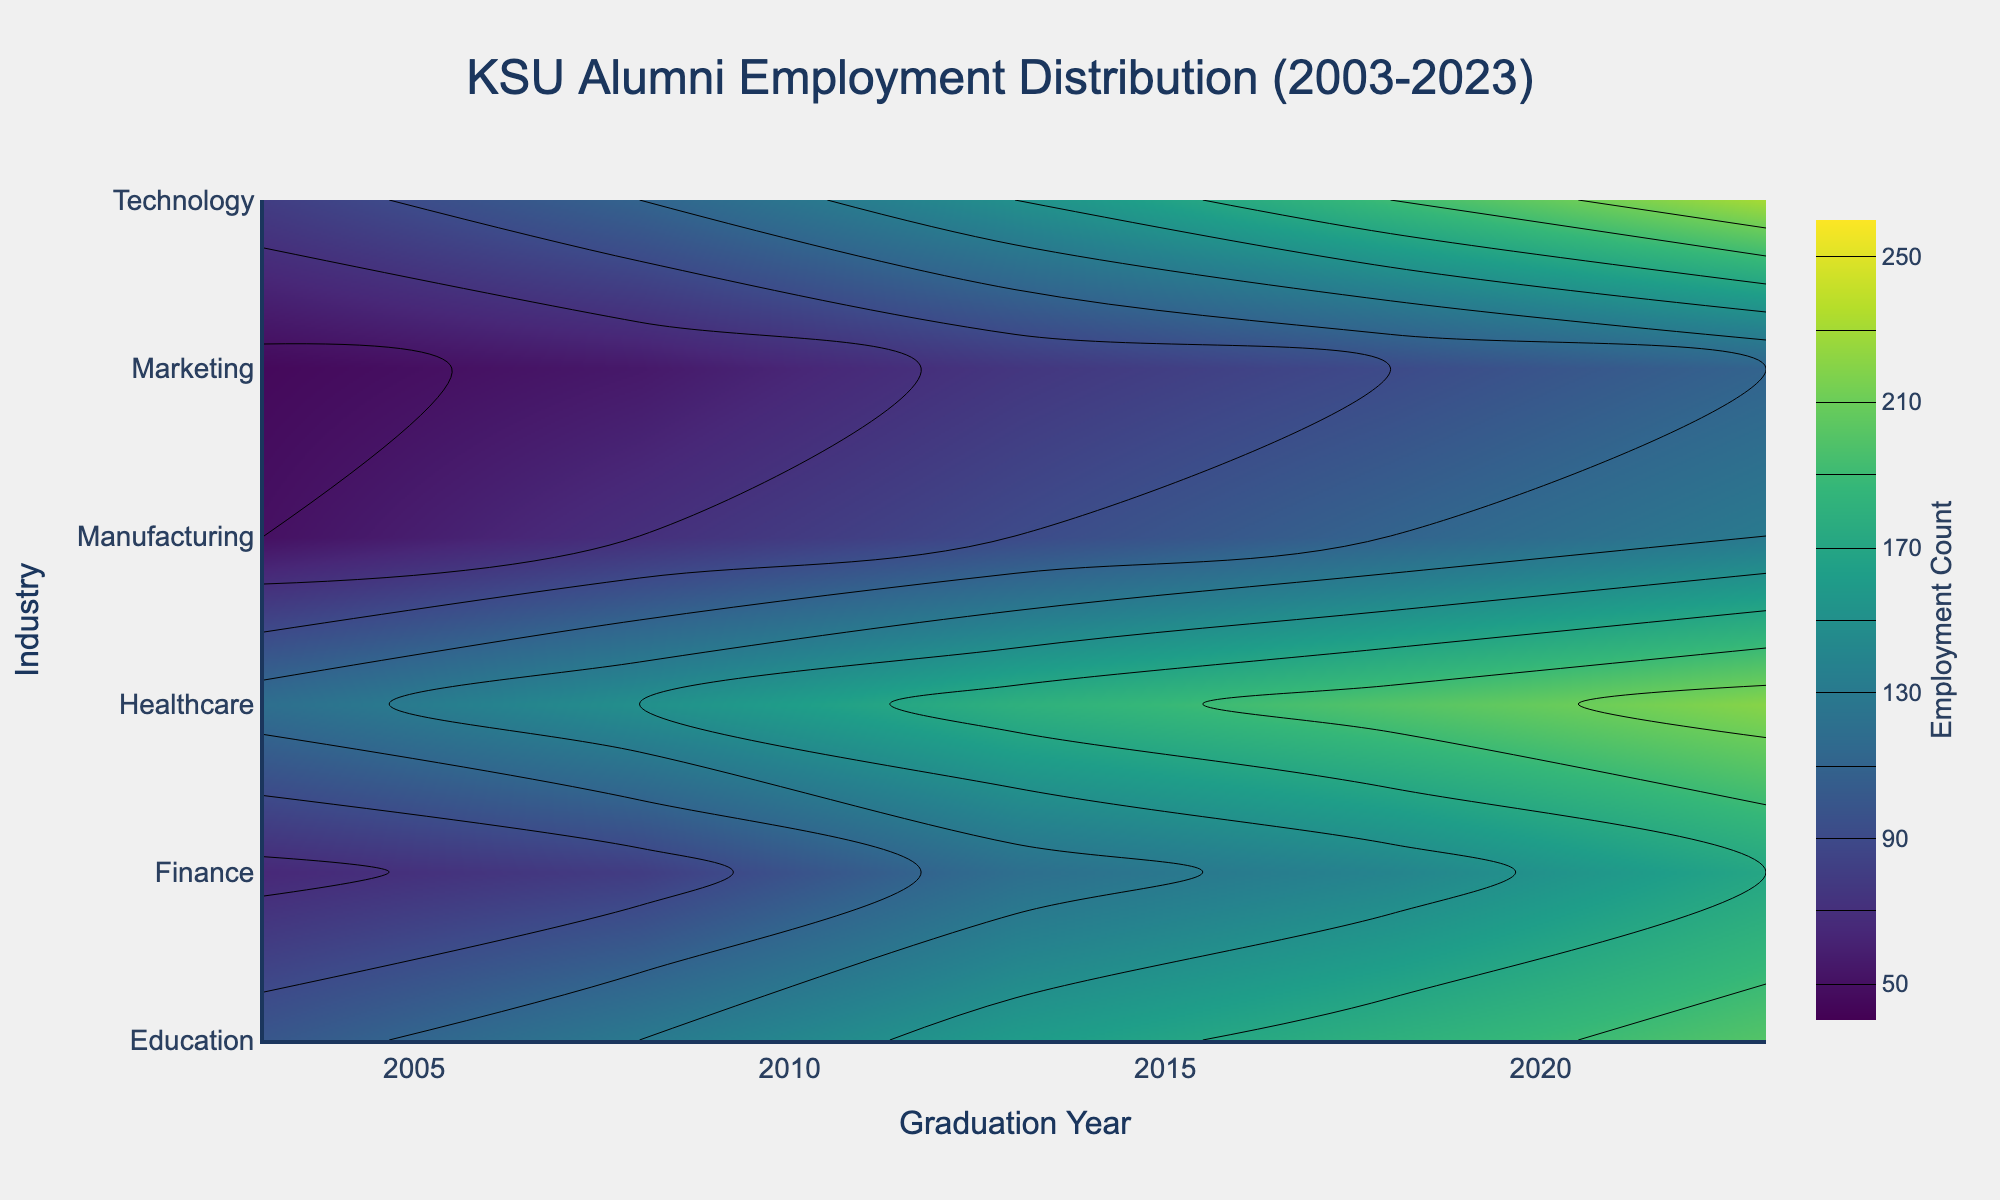What is the title of the figure? The title is displayed at the top of the figure.
Answer: KSU Alumni Employment Distribution (2003-2023) Which industry had the highest employment count in 2023? The contour plot shows the highest density areas, and for 2023, Technology has the highest employment count.
Answer: Technology By how many employment counts did the Healthcare industry increase from 2003 to 2023? In 2003, Healthcare had 120 employment counts. In 2023, it had 220. The increase is 220 - 120 = 100.
Answer: 100 Which industry showed the most significant increase in employment count from 2003 to 2023? By comparing the changes in all industries over the years, Technology increased from 80 in 2003 to 230 in 2023, showing the largest increase.
Answer: Technology What is the general trend of employment in the Education industry from 2003 to 2023? Observing the contour plot, employment in Education increases steadily from 2003 (100) to 2023 (200).
Answer: Increasing Which year saw the highest employment count in Manufacturing, and what was the count? In 2023, Manufacturing reached its peak employment count of 130, as seen from the contour lines' density.
Answer: 2023, 130 Compare the employment counts in Finance and Marketing in 2018. Which had more? In the contour plot, Finance in 2018 has an employment count of 140, whereas Marketing has 90. Finance is higher.
Answer: Finance What is the average employment count in the Technology industry over all the years displayed? Adding employment counts for Technology: 80 (2003) + 110 (2008) + 150 (2013) + 190 (2018) + 230 (2023) = 760. Dividing by 5, the average is 760/5 = 152.
Answer: 152 Is there any industry whose employment count consistently increased over every graduation year from 2003 to 2023? By checking each industry's trend line, both Healthcare and Technology show consistent increases each year.
Answer: Healthcare, Technology Identify the years when the employment count in the Finance industry was below 100. In the contour plot for Finance: 2003 (65), 2008 (80) and 2013 (120). So, 2003 and 2008 had counts below 100.
Answer: 2003, 2008 